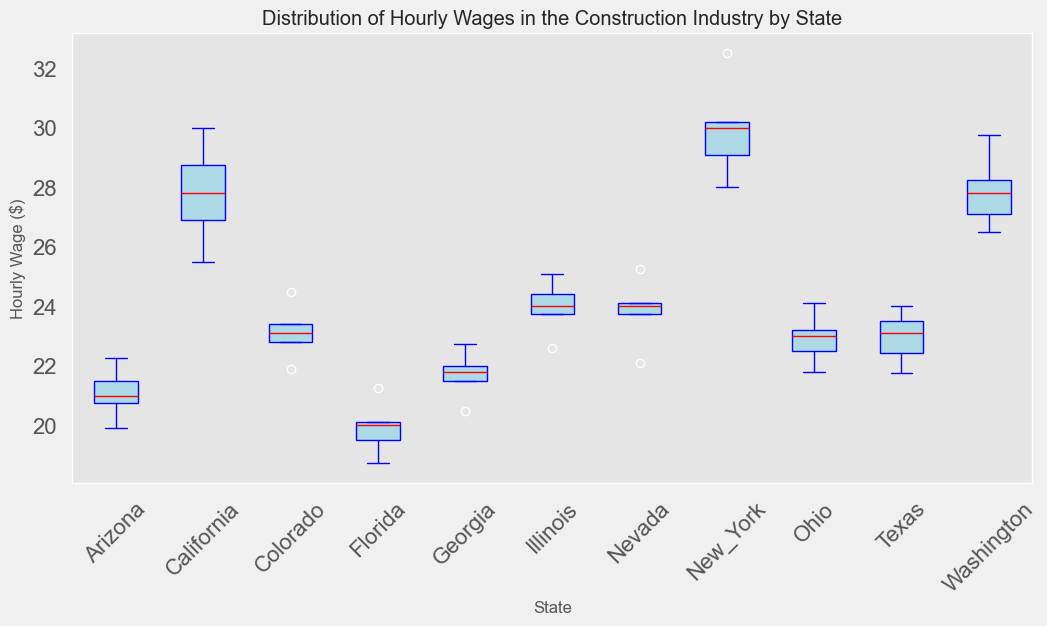Which state has the highest median hourly wage? To find the state with the highest median hourly wage, look for the red line inside each box plot that represents the median. The state with the highest positioned red line has the highest median hourly wage.
Answer: New York Which state has the lowest minimum hourly wage? The minimum wage is represented by the bottom whisker of each box plot. The state with the lowest positioned bottom whisker has the lowest minimum hourly wage.
Answer: Florida Compare the median hourly wage of California and Texas. Which one is higher, and by how much? Locate the red median lines for California and Texas. California's is higher. Subtract the median value in Texas from the median value in California to find the difference.
Answer: California is higher by approximately $4.90 Which state shows the widest range of hourly wages? The range of hourly wages in each state is represented by the distance between the top and bottom whiskers of each box plot. The state with the largest distance between whiskers has the widest range.
Answer: New York How does the distribution of hourly wages in Colorado compare to Nevada? Compare the box plots of Colorado and Nevada. Look at the spread (Interquartile Range - IQR), median, and range (whiskers) of the box plots to see the differences and similarities.
Answer: Colorado has a narrower IQR and lower median than Nevada, but their ranges overlap significantly Is the median hourly wage in Washington closer to the maximum hourly wage or the minimum hourly wage? Identify the red median line within Washington's box plot, and compare its position relative to the top (maximum) and bottom (minimum) whiskers.
Answer: Closer to the minimum hourly wage Which state has the most consistent hourly wage (least variability)? Consistent wages are indicated by a smaller interquartile range (IQR) and shorter whiskers. The state with the smallest box and shortest whiskers has the most consistent wages.
Answer: Georgia How does the hourly wage distribution in Arizona compare to Florida? Compare the box plots for Arizona and Florida by looking at their medians, IQRs, and ranges.
Answer: Arizona has a slightly higher median and a slightly narrower IQR compared to Florida What is the interquartile range (IQR) of hourly wages in Texas? The IQR is represented by the height of the box itself. Calculate the difference between the top of the box (75th percentile) and the bottom of the box (25th percentile) for Texas.
Answer: Approximately $2.25 Identify the state with the largest difference between the median and the maximum hourly wage. To find this, look at the distance from the red median line to the top whisker in each box plot. The state with the largest distance has the largest difference between median and maximum hourly wage.
Answer: New York 